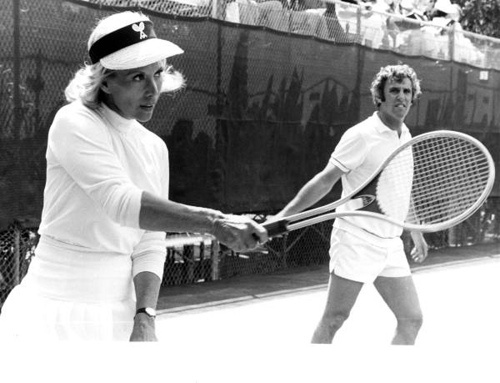Describe the objects in this image and their specific colors. I can see people in gray, white, darkgray, and black tones, people in gray, white, darkgray, dimgray, and black tones, and tennis racket in gray, lightgray, darkgray, and black tones in this image. 